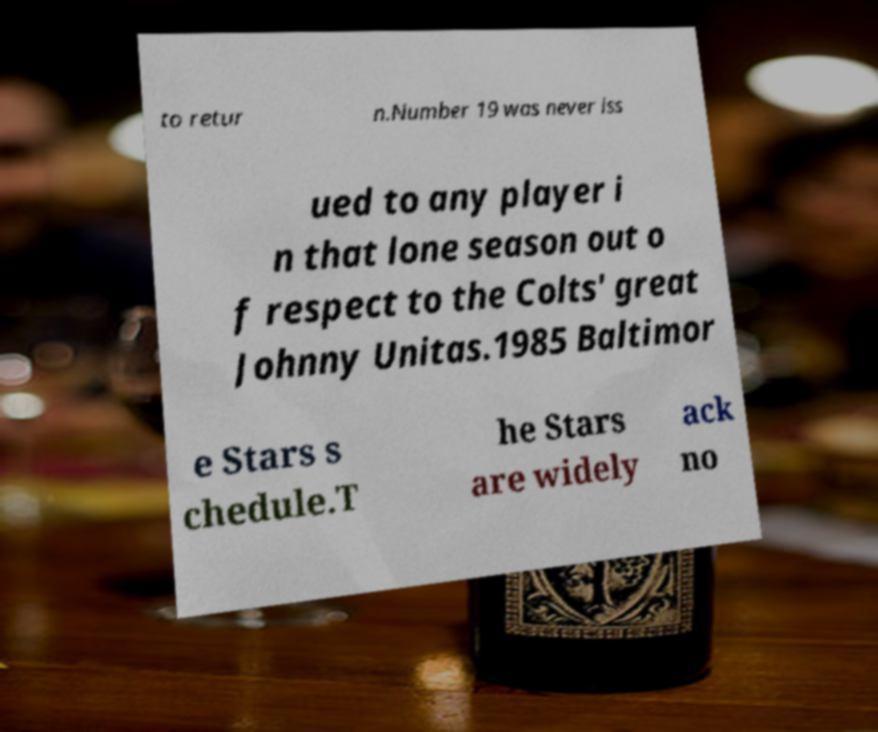Could you assist in decoding the text presented in this image and type it out clearly? to retur n.Number 19 was never iss ued to any player i n that lone season out o f respect to the Colts' great Johnny Unitas.1985 Baltimor e Stars s chedule.T he Stars are widely ack no 